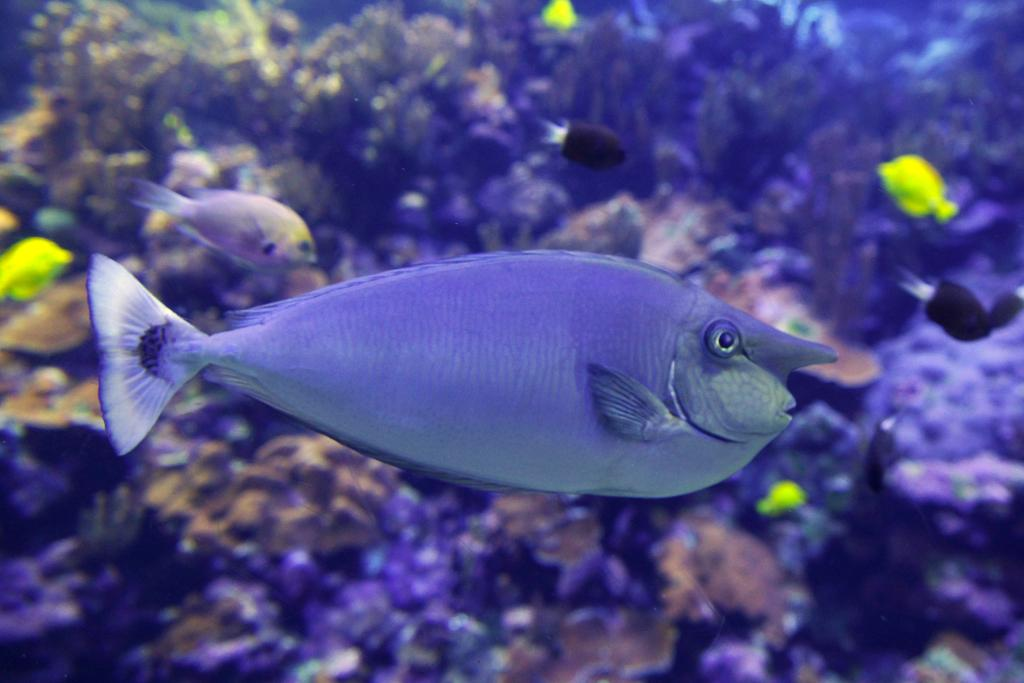What is the main subject of the image? There is a fish in the image. Where was the image taken? The image is taken in the water. What can be seen in the background of the image? There are small plants and other fishes visible in the background. What type of game is being played in the image? There is no game being played in the image; it features a fish in the water. Can you provide an example of the apparel worn by the fish in the image? Fish do not wear apparel, so there is no example to provide. 